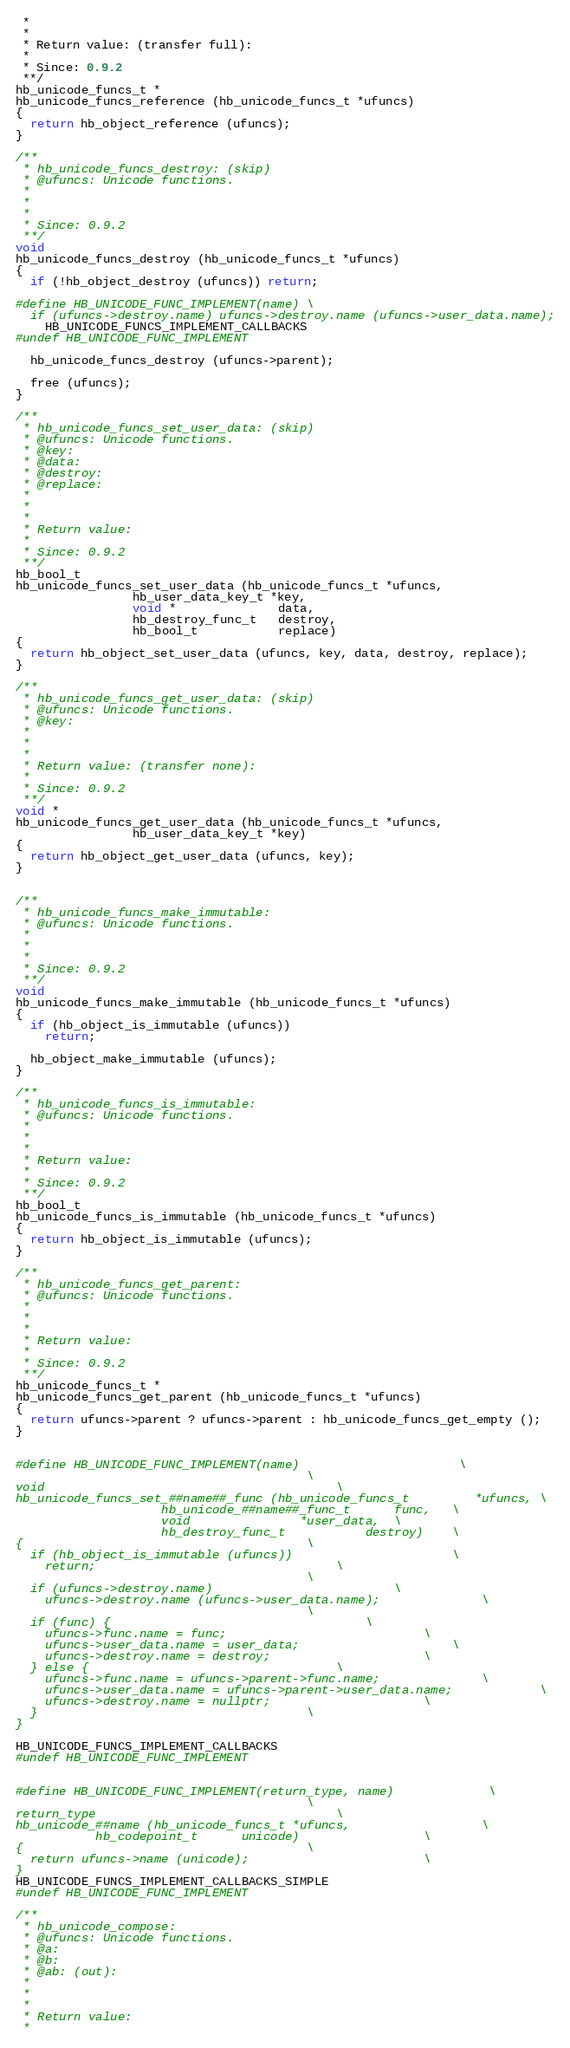Convert code to text. <code><loc_0><loc_0><loc_500><loc_500><_C++_> *
 *
 * Return value: (transfer full):
 *
 * Since: 0.9.2
 **/
hb_unicode_funcs_t *
hb_unicode_funcs_reference (hb_unicode_funcs_t *ufuncs)
{
  return hb_object_reference (ufuncs);
}

/**
 * hb_unicode_funcs_destroy: (skip)
 * @ufuncs: Unicode functions.
 *
 *
 *
 * Since: 0.9.2
 **/
void
hb_unicode_funcs_destroy (hb_unicode_funcs_t *ufuncs)
{
  if (!hb_object_destroy (ufuncs)) return;

#define HB_UNICODE_FUNC_IMPLEMENT(name) \
  if (ufuncs->destroy.name) ufuncs->destroy.name (ufuncs->user_data.name);
    HB_UNICODE_FUNCS_IMPLEMENT_CALLBACKS
#undef HB_UNICODE_FUNC_IMPLEMENT

  hb_unicode_funcs_destroy (ufuncs->parent);

  free (ufuncs);
}

/**
 * hb_unicode_funcs_set_user_data: (skip)
 * @ufuncs: Unicode functions.
 * @key:
 * @data:
 * @destroy:
 * @replace:
 *
 *
 *
 * Return value:
 *
 * Since: 0.9.2
 **/
hb_bool_t
hb_unicode_funcs_set_user_data (hb_unicode_funcs_t *ufuncs,
				hb_user_data_key_t *key,
				void *              data,
				hb_destroy_func_t   destroy,
				hb_bool_t           replace)
{
  return hb_object_set_user_data (ufuncs, key, data, destroy, replace);
}

/**
 * hb_unicode_funcs_get_user_data: (skip)
 * @ufuncs: Unicode functions.
 * @key:
 *
 *
 *
 * Return value: (transfer none):
 *
 * Since: 0.9.2
 **/
void *
hb_unicode_funcs_get_user_data (hb_unicode_funcs_t *ufuncs,
				hb_user_data_key_t *key)
{
  return hb_object_get_user_data (ufuncs, key);
}


/**
 * hb_unicode_funcs_make_immutable:
 * @ufuncs: Unicode functions.
 *
 *
 *
 * Since: 0.9.2
 **/
void
hb_unicode_funcs_make_immutable (hb_unicode_funcs_t *ufuncs)
{
  if (hb_object_is_immutable (ufuncs))
    return;

  hb_object_make_immutable (ufuncs);
}

/**
 * hb_unicode_funcs_is_immutable:
 * @ufuncs: Unicode functions.
 *
 *
 *
 * Return value:
 *
 * Since: 0.9.2
 **/
hb_bool_t
hb_unicode_funcs_is_immutable (hb_unicode_funcs_t *ufuncs)
{
  return hb_object_is_immutable (ufuncs);
}

/**
 * hb_unicode_funcs_get_parent:
 * @ufuncs: Unicode functions.
 *
 *
 *
 * Return value:
 *
 * Since: 0.9.2
 **/
hb_unicode_funcs_t *
hb_unicode_funcs_get_parent (hb_unicode_funcs_t *ufuncs)
{
  return ufuncs->parent ? ufuncs->parent : hb_unicode_funcs_get_empty ();
}


#define HB_UNICODE_FUNC_IMPLEMENT(name)						\
										\
void										\
hb_unicode_funcs_set_##name##_func (hb_unicode_funcs_t		   *ufuncs,	\
				    hb_unicode_##name##_func_t	    func,	\
				    void			   *user_data,	\
				    hb_destroy_func_t		    destroy)	\
{										\
  if (hb_object_is_immutable (ufuncs))						\
    return;									\
										\
  if (ufuncs->destroy.name)							\
    ufuncs->destroy.name (ufuncs->user_data.name);				\
										\
  if (func) {									\
    ufuncs->func.name = func;							\
    ufuncs->user_data.name = user_data;						\
    ufuncs->destroy.name = destroy;						\
  } else {									\
    ufuncs->func.name = ufuncs->parent->func.name;				\
    ufuncs->user_data.name = ufuncs->parent->user_data.name;			\
    ufuncs->destroy.name = nullptr;						\
  }										\
}

HB_UNICODE_FUNCS_IMPLEMENT_CALLBACKS
#undef HB_UNICODE_FUNC_IMPLEMENT


#define HB_UNICODE_FUNC_IMPLEMENT(return_type, name)				\
										\
return_type									\
hb_unicode_##name (hb_unicode_funcs_t *ufuncs,					\
		   hb_codepoint_t      unicode)					\
{										\
  return ufuncs->name (unicode);						\
}
HB_UNICODE_FUNCS_IMPLEMENT_CALLBACKS_SIMPLE
#undef HB_UNICODE_FUNC_IMPLEMENT

/**
 * hb_unicode_compose:
 * @ufuncs: Unicode functions.
 * @a:
 * @b:
 * @ab: (out):
 *
 *
 *
 * Return value:
 *</code> 